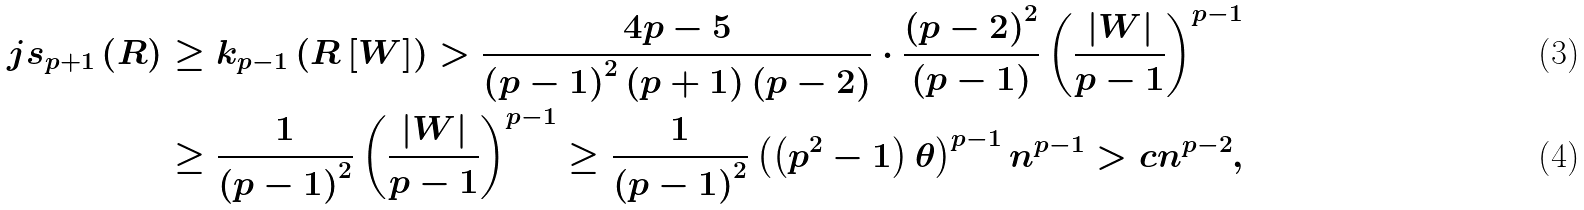<formula> <loc_0><loc_0><loc_500><loc_500>j s _ { p + 1 } \left ( R \right ) & \geq k _ { p - 1 } \left ( R \left [ W \right ] \right ) > \frac { 4 p - 5 } { \left ( p - 1 \right ) ^ { 2 } \left ( p + 1 \right ) \left ( p - 2 \right ) } \cdot \frac { \left ( p - 2 \right ) ^ { 2 } } { \left ( p - 1 \right ) } \left ( \frac { \left | W \right | } { p - 1 } \right ) ^ { p - 1 } \\ & \geq \frac { 1 } { \left ( p - 1 \right ) ^ { 2 } } \left ( \frac { \left | W \right | } { p - 1 } \right ) ^ { p - 1 } \geq \frac { 1 } { \left ( p - 1 \right ) ^ { 2 } } \left ( \left ( p ^ { 2 } - 1 \right ) \theta \right ) ^ { p - 1 } n ^ { p - 1 } > c n ^ { p - 2 } ,</formula> 